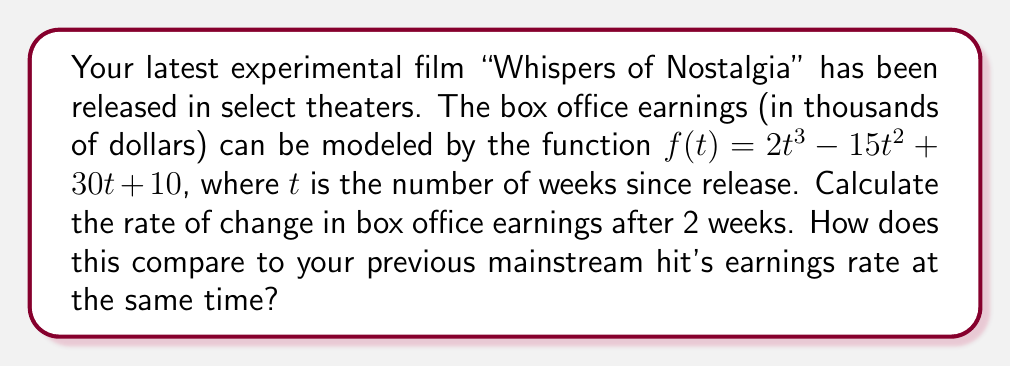Could you help me with this problem? To find the rate of change in box office earnings, we need to calculate the derivative of the given function and evaluate it at $t=2$.

1. Given function: $f(t) = 2t^3 - 15t^2 + 30t + 10$

2. Calculate the derivative:
   $$\frac{df}{dt} = 6t^2 - 30t + 30$$

3. Evaluate the derivative at $t=2$:
   $$\frac{df}{dt}(2) = 6(2)^2 - 30(2) + 30$$
   $$= 24 - 60 + 30 = -6$$

4. Interpret the result:
   The rate of change after 2 weeks is -6 thousand dollars per week. This means the box office earnings are decreasing at a rate of $6,000 per week at this point.

5. Compare to previous mainstream hit:
   The negative rate of change suggests that the experimental film's earnings are declining, which is in contrast to typical mainstream hits that often have positive growth rates in the early weeks. This comparison highlights the financial risks associated with experimental films and the desire for more creative risks in filmmaking.
Answer: $-6$ thousand dollars per week 